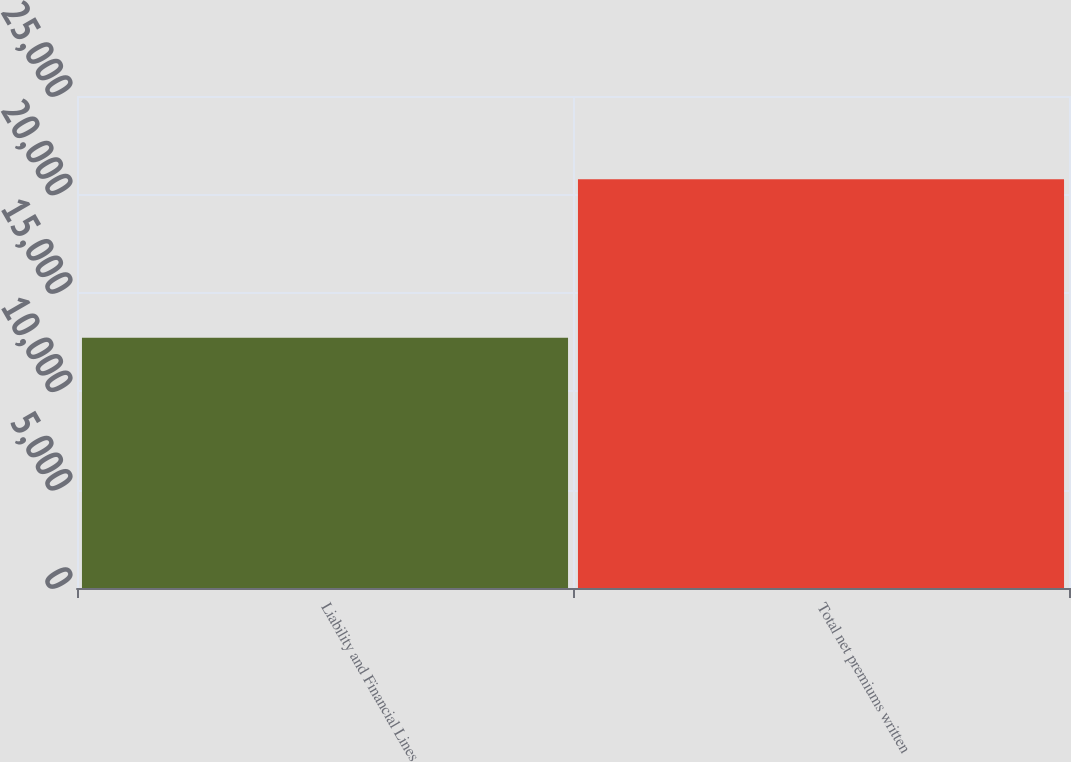<chart> <loc_0><loc_0><loc_500><loc_500><bar_chart><fcel>Liability and Financial Lines<fcel>Total net premiums written<nl><fcel>12718<fcel>20773<nl></chart> 